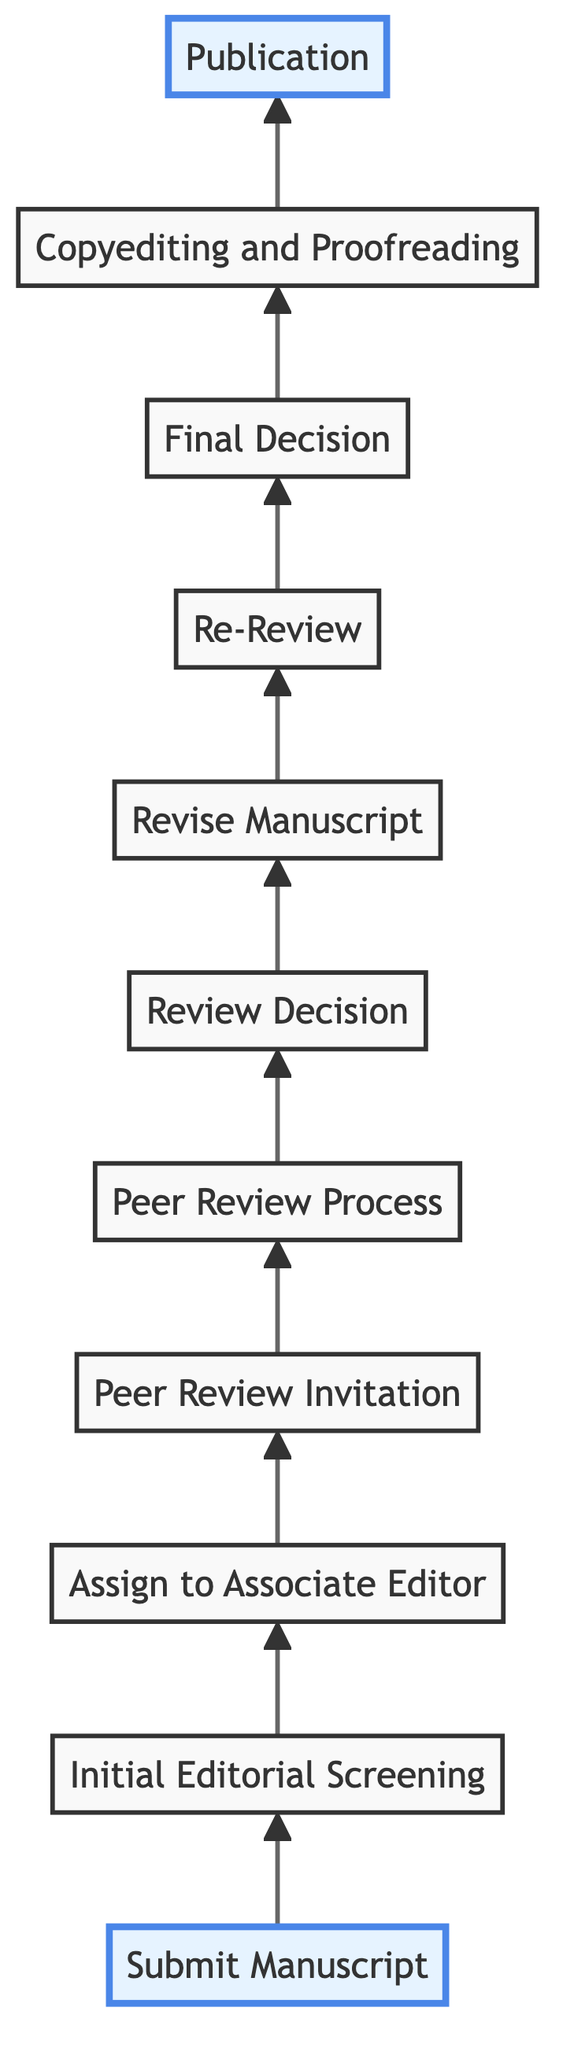What is the first step in the process? The flowchart starts with the "Submit Manuscript" node at the bottom, which indicates that the first action in the peer review process is to submit the completed manuscript.
Answer: Submit Manuscript How many nodes are there in the flowchart? By counting each labeled step in the chart from "Submit Manuscript" to "Publication," there are a total of 11 nodes.
Answer: 11 What happens after the "Peer Review Invitation"? After the "Peer Review Invitation," the next step is the "Peer Review Process," where the invited experts evaluate the manuscript.
Answer: Peer Review Process What decision can the associate editor make after the "Review Decision"? Following the "Review Decision," the associate editor can decide to either "Revise Manuscript" if changes are required or reject/accept it based on the reviews.
Answer: Revise Manuscript Is "Copyediting and Proofreading" before or after "Final Decision"? "Copyediting and Proofreading" occurs after "Final Decision," indicating that it's the final step in the process before publication.
Answer: After How does the process flow from "Re-Review" to the outcome? After "Re-Review," the process continues to "Final Decision," where the associate editor evaluates the revised manuscript before deciding to accept or reject it.
Answer: Final Decision What connects the "Revise Manuscript" to "Re-Review"? The flow directly connects "Revise Manuscript" to "Re-Review," indicating that once authors make revisions, the manuscript may need further evaluation.
Answer: Re-Review Which node represents the last step before the manuscript is published? The last step before publication is "Copyediting and Proofreading," where the manuscript is finalized for readability and accuracy.
Answer: Copyediting and Proofreading How many steps are there involved in the peer review process after submission? After the "Submit Manuscript," the flowchart outlines eight additional steps leading to publication, giving a total of nine steps in the process.
Answer: 9 